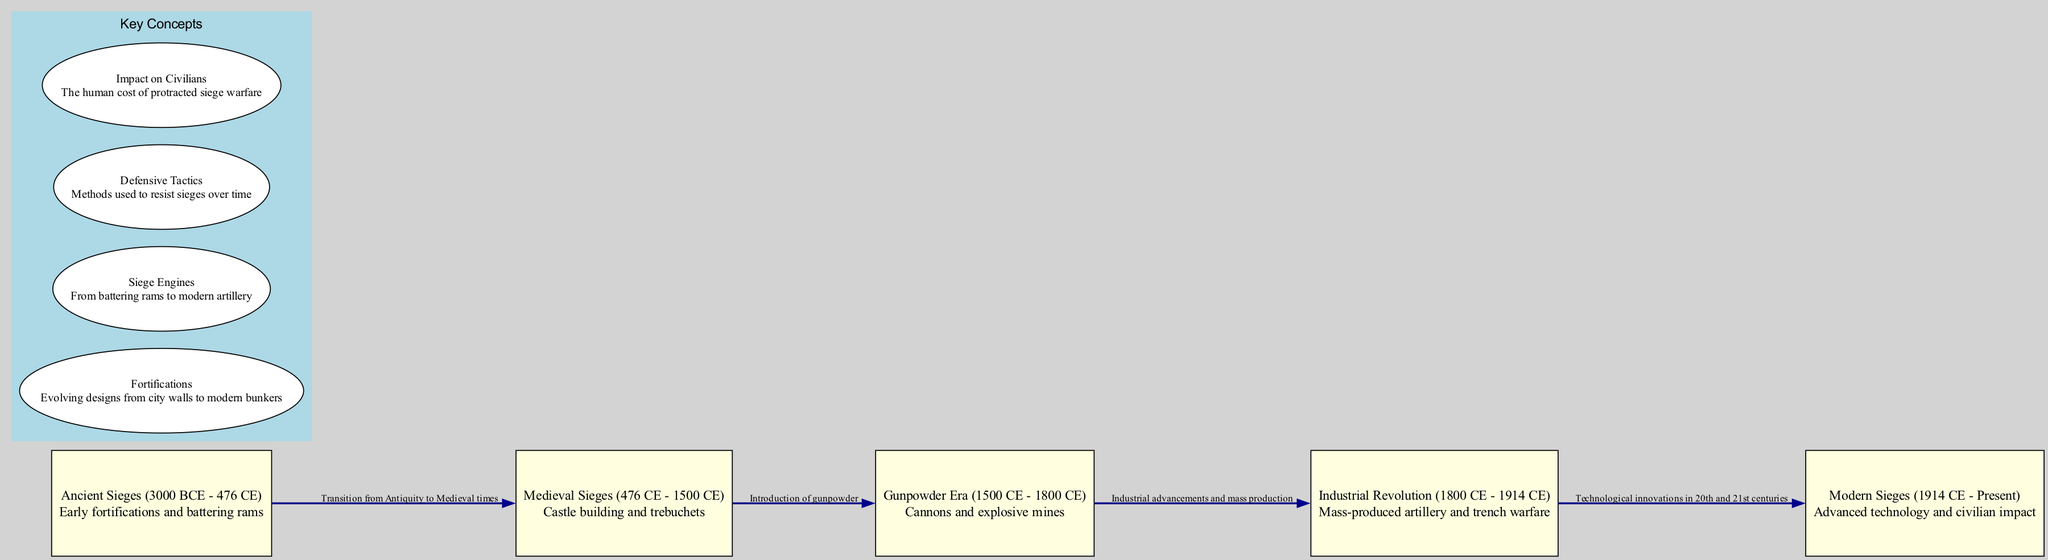What period does the "Modern Sieges" node represent? The "Modern Sieges" node indicates the period from 1914 CE to Present. This can be identified by looking at the label and description of the node which explicitly states the time range.
Answer: 1914 CE - Present What technology is highlighted in the "Gunpowder Era"? The "Gunpowder Era" node describes "Cannons and explosive mines." This information is directly available in the description of the corresponding node.
Answer: Cannons and explosive mines How many edges are in the diagram? The diagram contains four edges, which can be counted by reviewing the connections between the nodes that show the progression of siege warfare techniques over time.
Answer: 4 What transitional period is indicated by the edge from "Ancient Sieges" to "Medieval Sieges"? The edge from "Ancient Sieges" to "Medieval Sieges" describes this as a transition from Antiquity to Medieval times, as noted in the edge's description in the diagram.
Answer: Transition from Antiquity to Medieval times Which siege engine is mentioned in connection with the Medieval Sieges? The diagram specifically mentions "trebuchets" in the context of Medieval Sieges, as detailed in the description of that node.
Answer: Trebuchets Why does the Industrial Revolution result in advancements in siege warfare technology? The edge connecting "Gunpowder Era" to "Industrial Revolution" mentions industrial advancements and mass production as a reason for the technological changes during this period. Thus, the ability to mass-produce artillery enhanced siege warfare capabilities.
Answer: Industrial advancements and mass production What is the key concept associated with the impact of sieges on civilians? The key concept related to civilians is described as "Impact on Civilians," which outlines the human cost of protracted siege warfare, as provided in the key concepts section of the diagram.
Answer: Impact on Civilians How did siege warfare evolve from the Gunpowder Era to the Industrial Revolution? The transition from the Gunpowder Era to the Industrial Revolution is noted for its advancements due to industrialization and the mass production of artillery, reflecting a significant evolution in the methods and technologies used in siege warfare.
Answer: Technological advancements in mass production What describes the method used to resist sieges according to the key concepts? The key concept of "Defensive Tactics" is specifically described as the methods used to resist sieges over time, as defined in the key concepts section within the diagram.
Answer: Defensive Tactics 